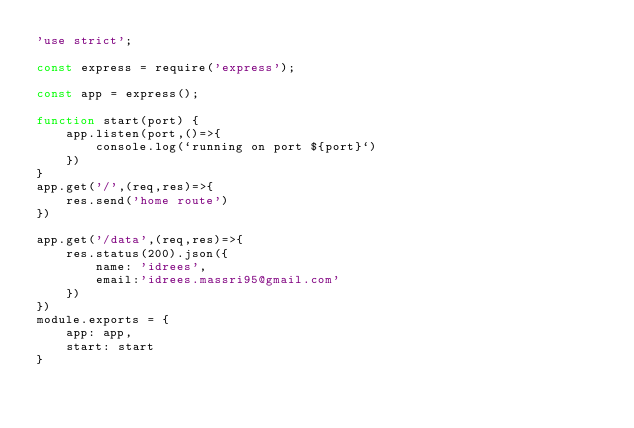Convert code to text. <code><loc_0><loc_0><loc_500><loc_500><_JavaScript_>'use strict';

const express = require('express');

const app = express();

function start(port) {
    app.listen(port,()=>{
        console.log(`running on port ${port}`)
    })
}
app.get('/',(req,res)=>{
    res.send('home route')
})

app.get('/data',(req,res)=>{
    res.status(200).json({
        name: 'idrees',
        email:'idrees.massri95@gmail.com'
    })
})
module.exports = {
    app: app,
    start: start
}</code> 